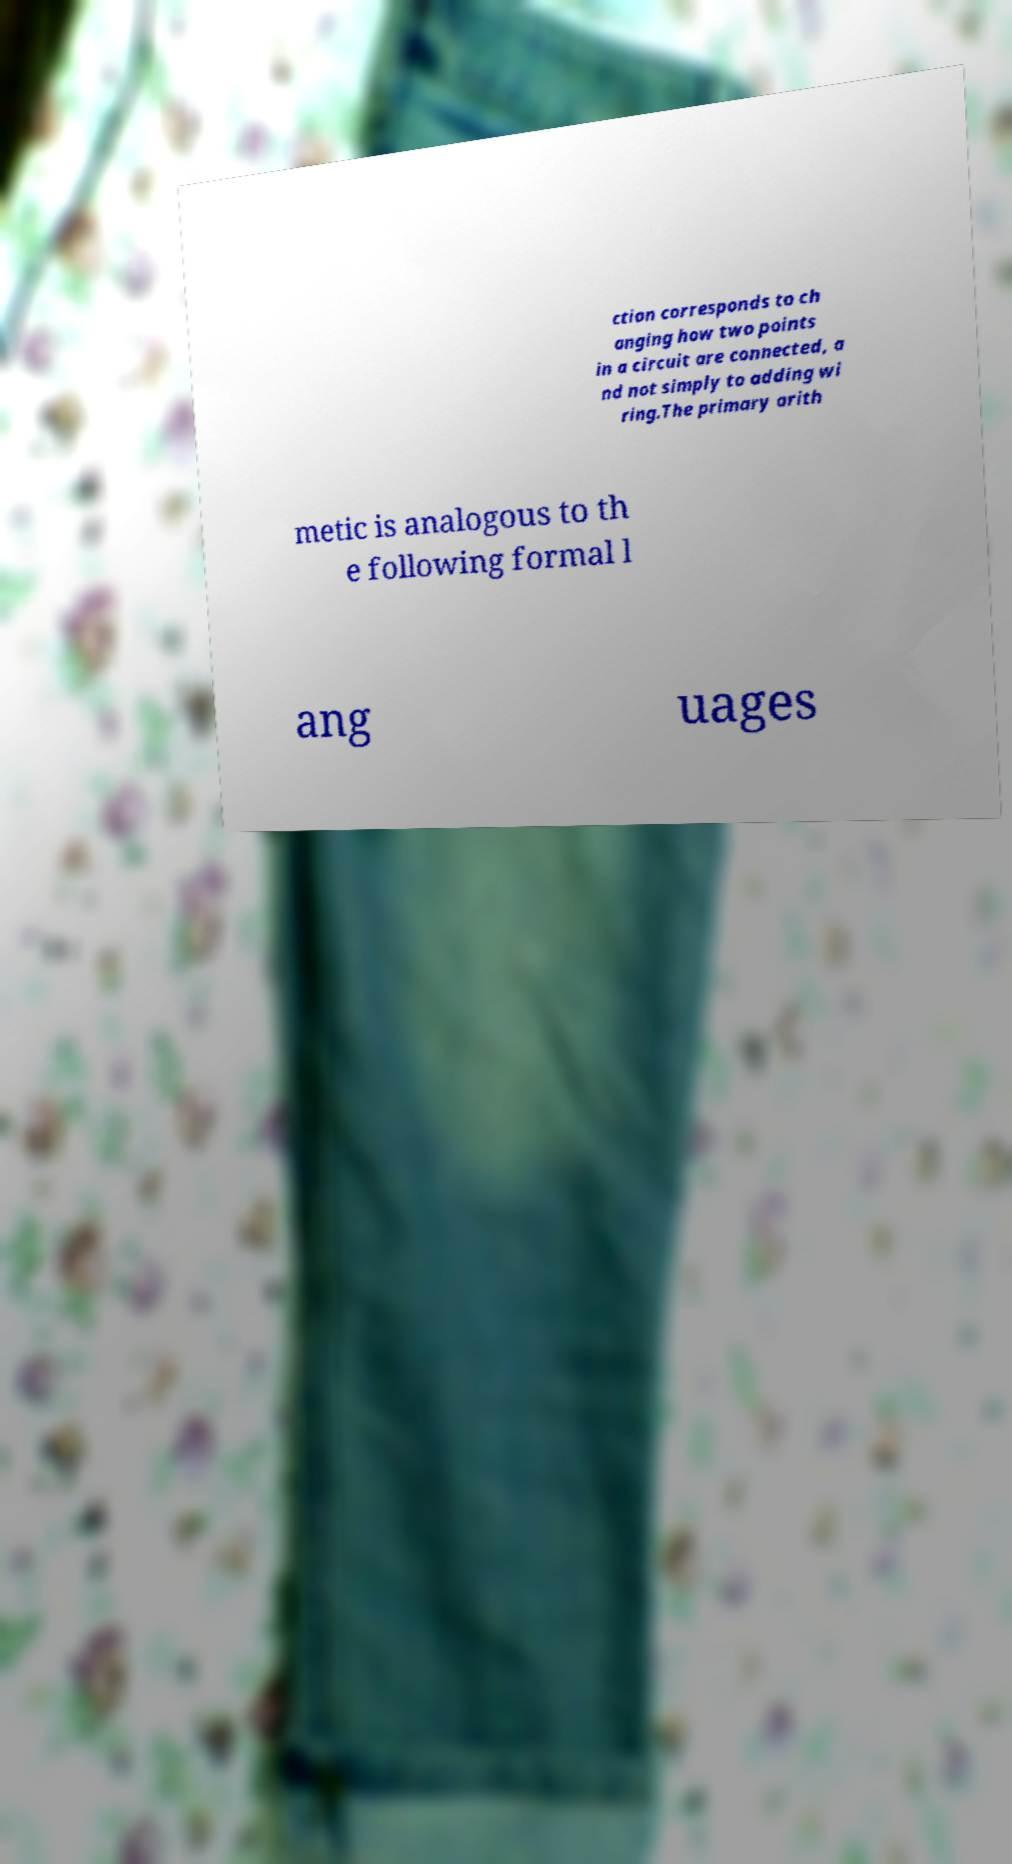Could you extract and type out the text from this image? ction corresponds to ch anging how two points in a circuit are connected, a nd not simply to adding wi ring.The primary arith metic is analogous to th e following formal l ang uages 